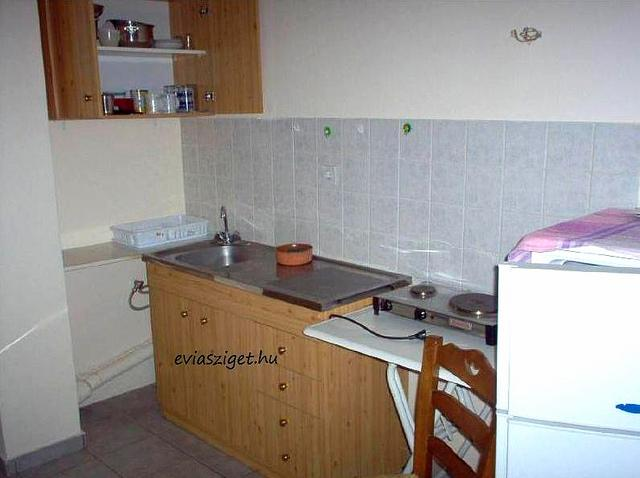What country is this?

Choices:
A) japan
B) usa
C) hungary
D) uk hungary 